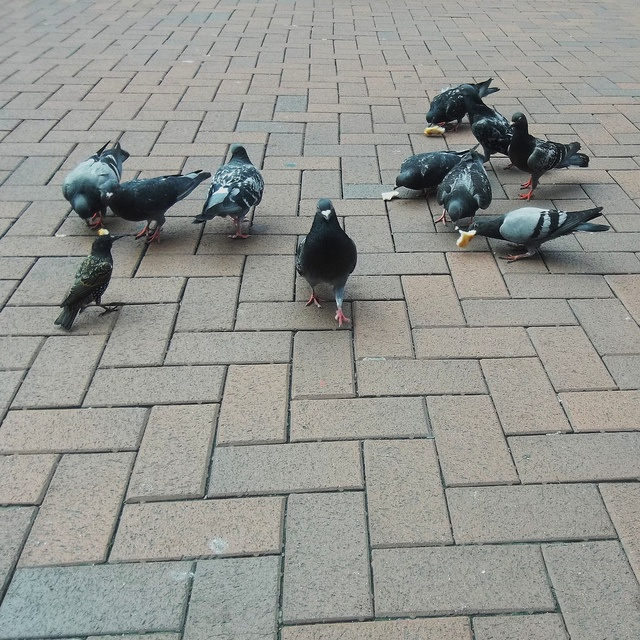Describe the objects in this image and their specific colors. I can see bird in darkgray, black, gray, and purple tones, bird in darkgray, black, gray, and purple tones, bird in darkgray, black, gray, and blue tones, bird in darkgray, black, blue, gray, and darkblue tones, and bird in darkgray, black, gray, and purple tones in this image. 